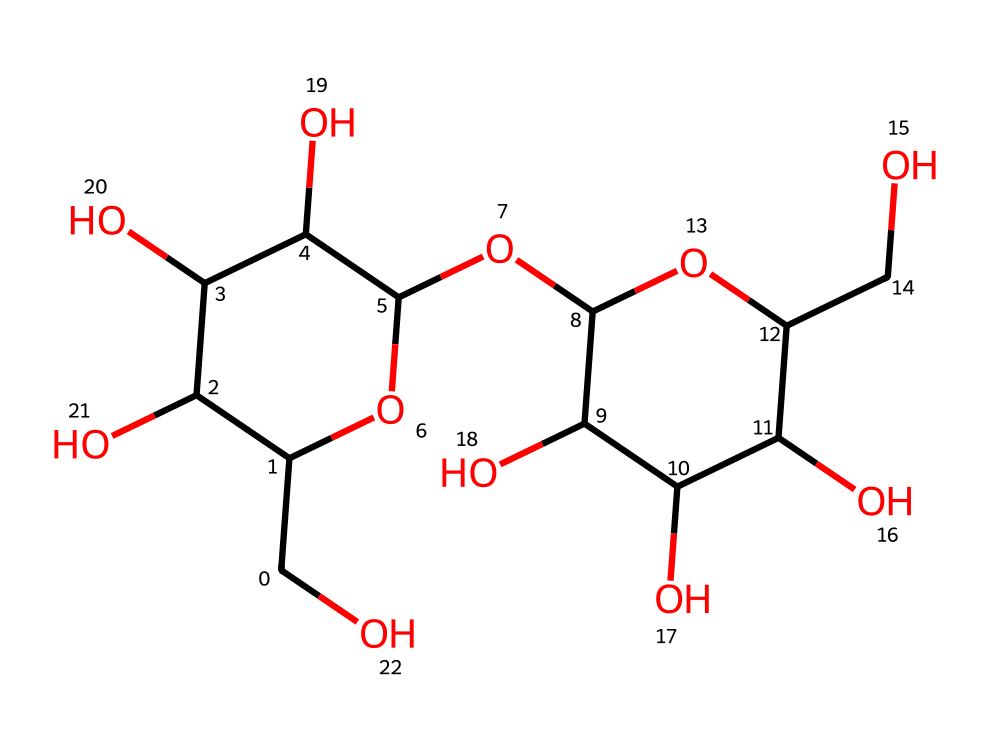What is the main type of carbohydrate represented by this structure? This chemical structure corresponds to glycogen, which is a polysaccharide, specifically a storage form of carbohydrate in animals.
Answer: glycogen How many carbon atoms are present in this structure? By analyzing the SMILES representation, there are 12 carbon atoms indicated in the linear chains and rings present in glycogen.
Answer: 12 What functional groups are present in the structure? The structure contains multiple hydroxyl (–OH) groups, characteristic of carbohydrates, facilitating hydrogen bonding and solubility in water.
Answer: hydroxyl groups How many hydroxyl groups are in the structure? Count each –OH group within the arrangement; there are seven hydroxyl groups present in the glycogen structure, aiding in its solubility.
Answer: 7 What type of glycosidic linkage is primarily found in glycogen? Glycogen primarily features α(1→4) glycosidic linkages within its chains and α(1→6) linkages at the branching points for storage efficiency.
Answer: α(1→4) and α(1→6) What is the purpose of the branching in the structure of glycogen? The branching in glycogen allows for rapid mobilization of glucose when energy is needed, increasing the number of terminal glucose units available for enzymatic action.
Answer: energy storage How does the molecular arrangement contribute to its function as a storage carbohydrate? The highly branched structure of glycogen means it can store a larger amount of glucose and allows for quick release during metabolic demand, making it efficient for energy storage in animals.
Answer: efficient energy storage 